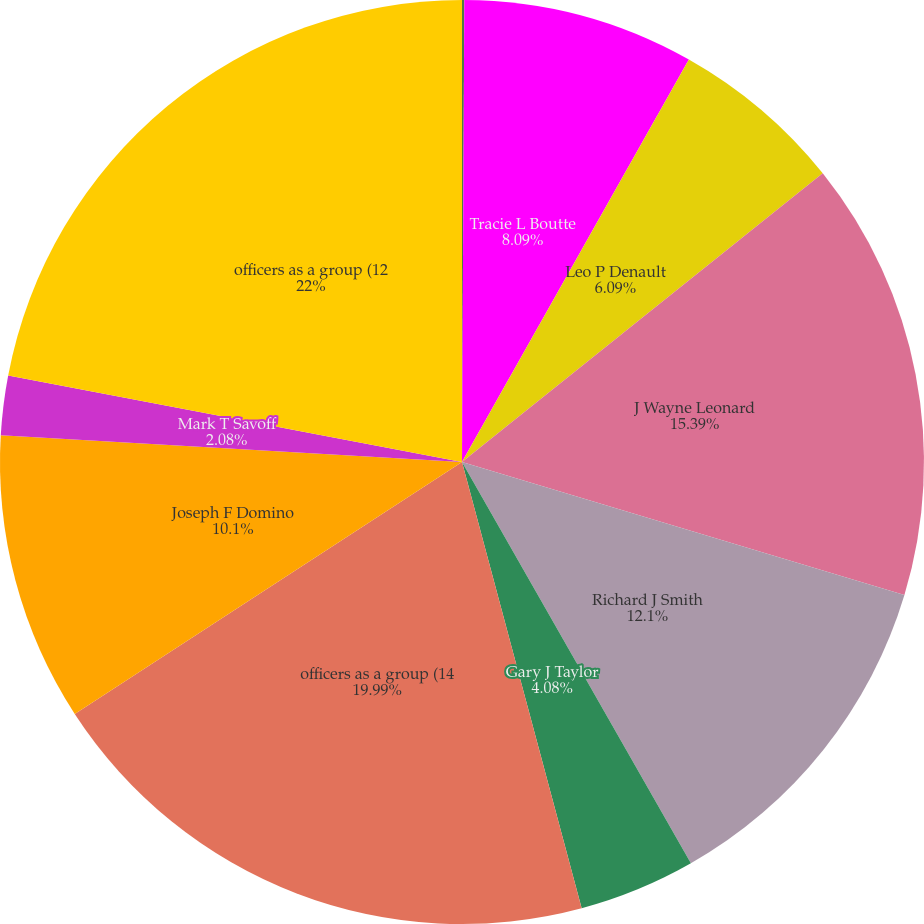Convert chart. <chart><loc_0><loc_0><loc_500><loc_500><pie_chart><fcel>Theodore H Bunting Jr<fcel>Tracie L Boutte<fcel>Leo P Denault<fcel>J Wayne Leonard<fcel>Richard J Smith<fcel>Gary J Taylor<fcel>officers as a group (14<fcel>Joseph F Domino<fcel>Mark T Savoff<fcel>officers as a group (12<nl><fcel>0.08%<fcel>8.09%<fcel>6.09%<fcel>15.39%<fcel>12.1%<fcel>4.08%<fcel>19.99%<fcel>10.1%<fcel>2.08%<fcel>22.0%<nl></chart> 